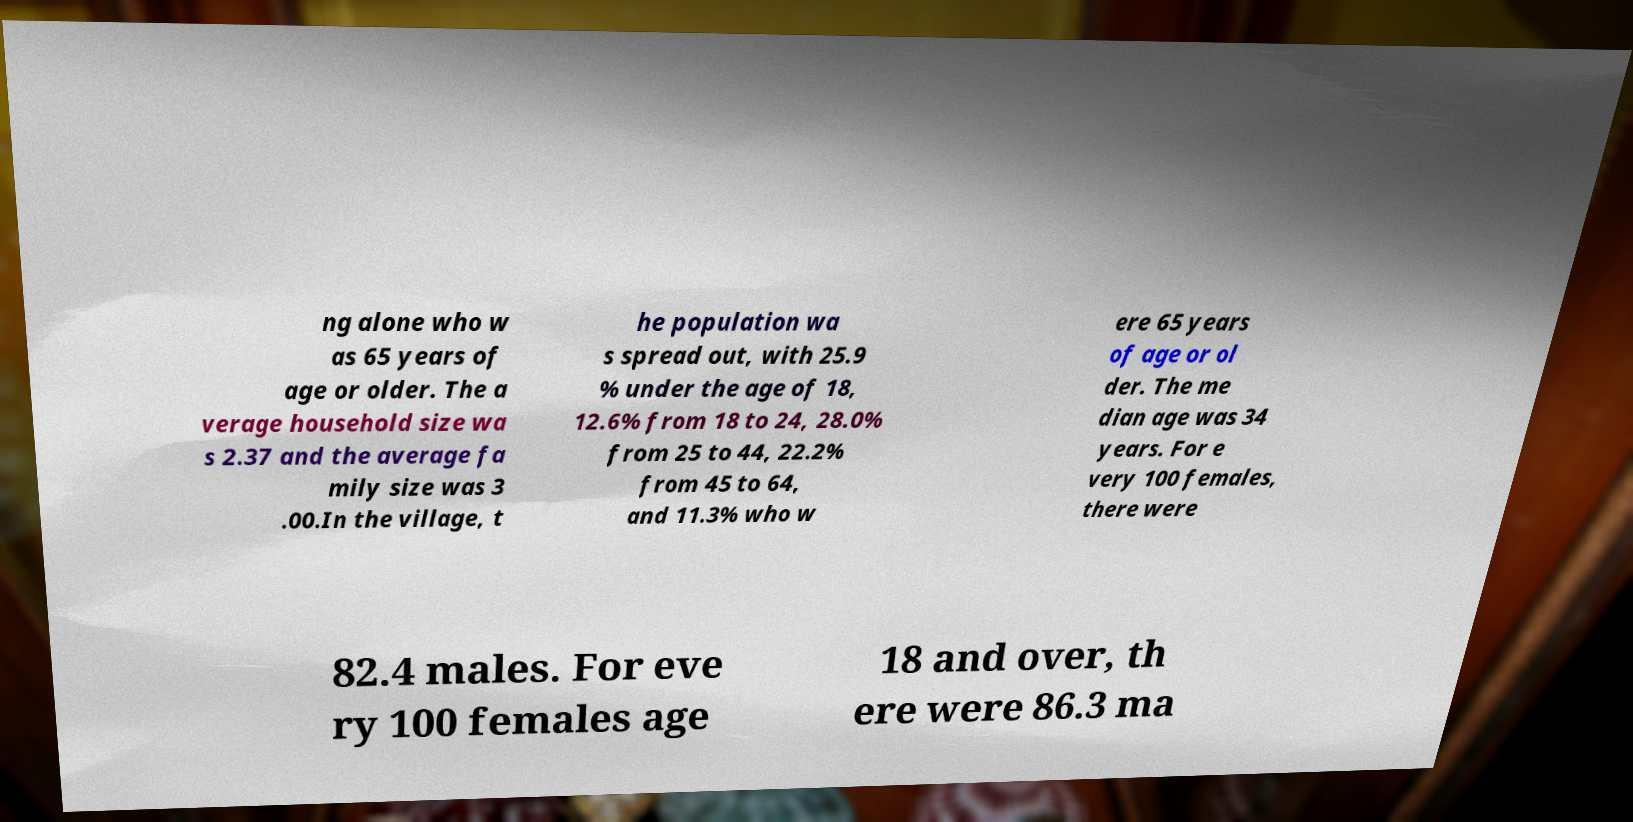Could you extract and type out the text from this image? ng alone who w as 65 years of age or older. The a verage household size wa s 2.37 and the average fa mily size was 3 .00.In the village, t he population wa s spread out, with 25.9 % under the age of 18, 12.6% from 18 to 24, 28.0% from 25 to 44, 22.2% from 45 to 64, and 11.3% who w ere 65 years of age or ol der. The me dian age was 34 years. For e very 100 females, there were 82.4 males. For eve ry 100 females age 18 and over, th ere were 86.3 ma 